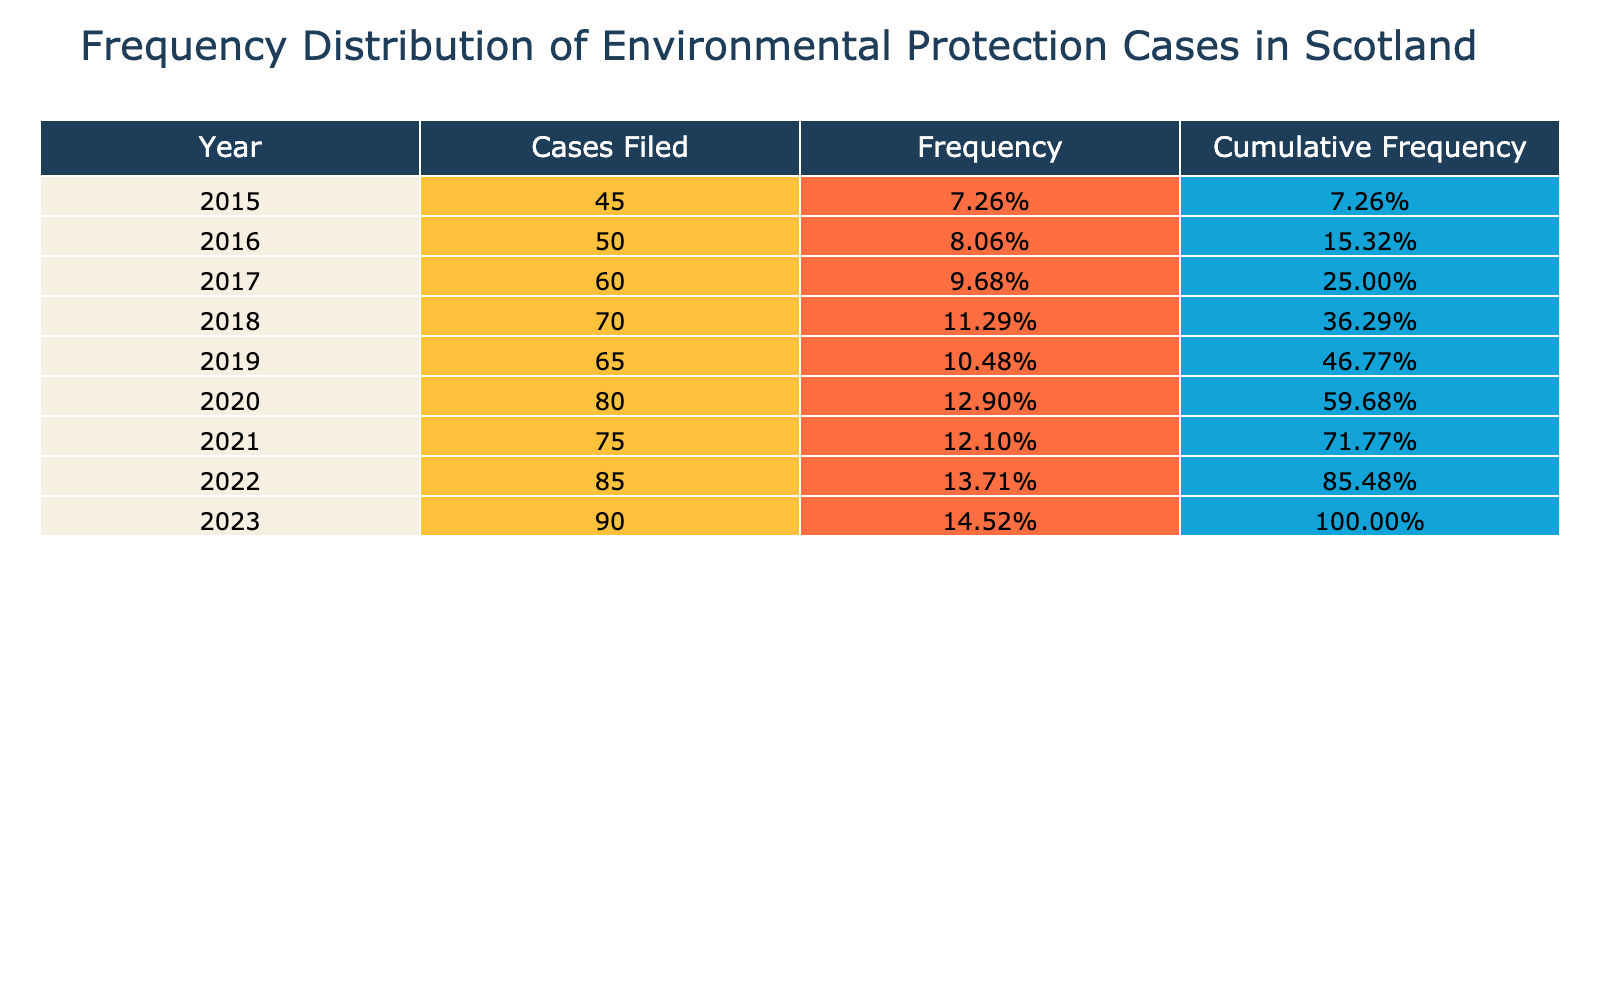What year had the highest number of environmental protection cases filed? By examining the "Number of Environmental Protection Cases Filed" column, we can see that the highest value is 90, which corresponds to the year 2023.
Answer: 2023 What was the cumulative frequency of cases filed by the end of 2021? To find the cumulative frequency for 2021, we can look at the Cumulative Frequency column for that year, which shows 72.73%. This percentage reflects the total proportion of cases filed up to and including 2021.
Answer: 72.73% Did the number of cases filed increase every year from 2015 to 2023? We evaluate each year's filing numbers. From 2015 to 2018, the cases increased each year. However, from 2018 to 2019, the cases decreased from 70 to 65. Thus, the statement is false.
Answer: No What is the total number of environmental protection cases filed from 2015 to 2023? To find the total, we sum the cases filed in each year: 45 + 50 + 60 + 70 + 65 + 80 + 75 + 85 + 90 = 615. Therefore, the total number of cases is 615.
Answer: 615 What was the average number of environmental protection cases filed per year from 2015 to 2023? We calculate the average by taking the total from the previous question (615) and dividing it by the number of years (9): 615 / 9 = 68.33. Therefore, the average number of cases filed per year is approximately 68.33.
Answer: 68.33 In which year was the frequency of filed cases the lowest? The frequency is calculated based on the number of cases filed relative to the total. The lowest value corresponds to the year 2015 when 45 cases constituted a lower proportion relative to the total cases for that period.
Answer: 2015 Was there a decrease in the number of cases filed from 2018 to 2019? By comparing the values of 2018 (70 cases) and 2019 (65 cases), we can see that there was a decrease. Therefore, the statement is true.
Answer: Yes What percentage increase in the number of cases filed occurred from 2020 to 2023? We calculate the increase from 2020 (80 cases) to 2023 (90 cases). The difference is 90 - 80 = 10. To find the percentage increase, we divide this difference by the 2020 figure: (10/80) * 100 = 12.5%.
Answer: 12.5% 